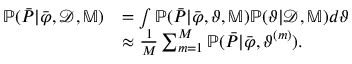Convert formula to latex. <formula><loc_0><loc_0><loc_500><loc_500>\begin{array} { r l } { \mathbb { P } ( \bar { P } | \bar { \varphi } , \mathcal { D } , \mathbb { M } ) } & { = \int \mathbb { P } ( \bar { P } | \bar { \varphi } , \vartheta , \mathbb { M } ) \mathbb { P } ( \vartheta | \mathcal { D } , \mathbb { M } ) d \vartheta } \\ & { \approx \frac { 1 } { M } \sum _ { m = 1 } ^ { M } \mathbb { P } ( \bar { P } | \bar { \varphi } , \vartheta ^ { ( m ) } ) . } \end{array}</formula> 